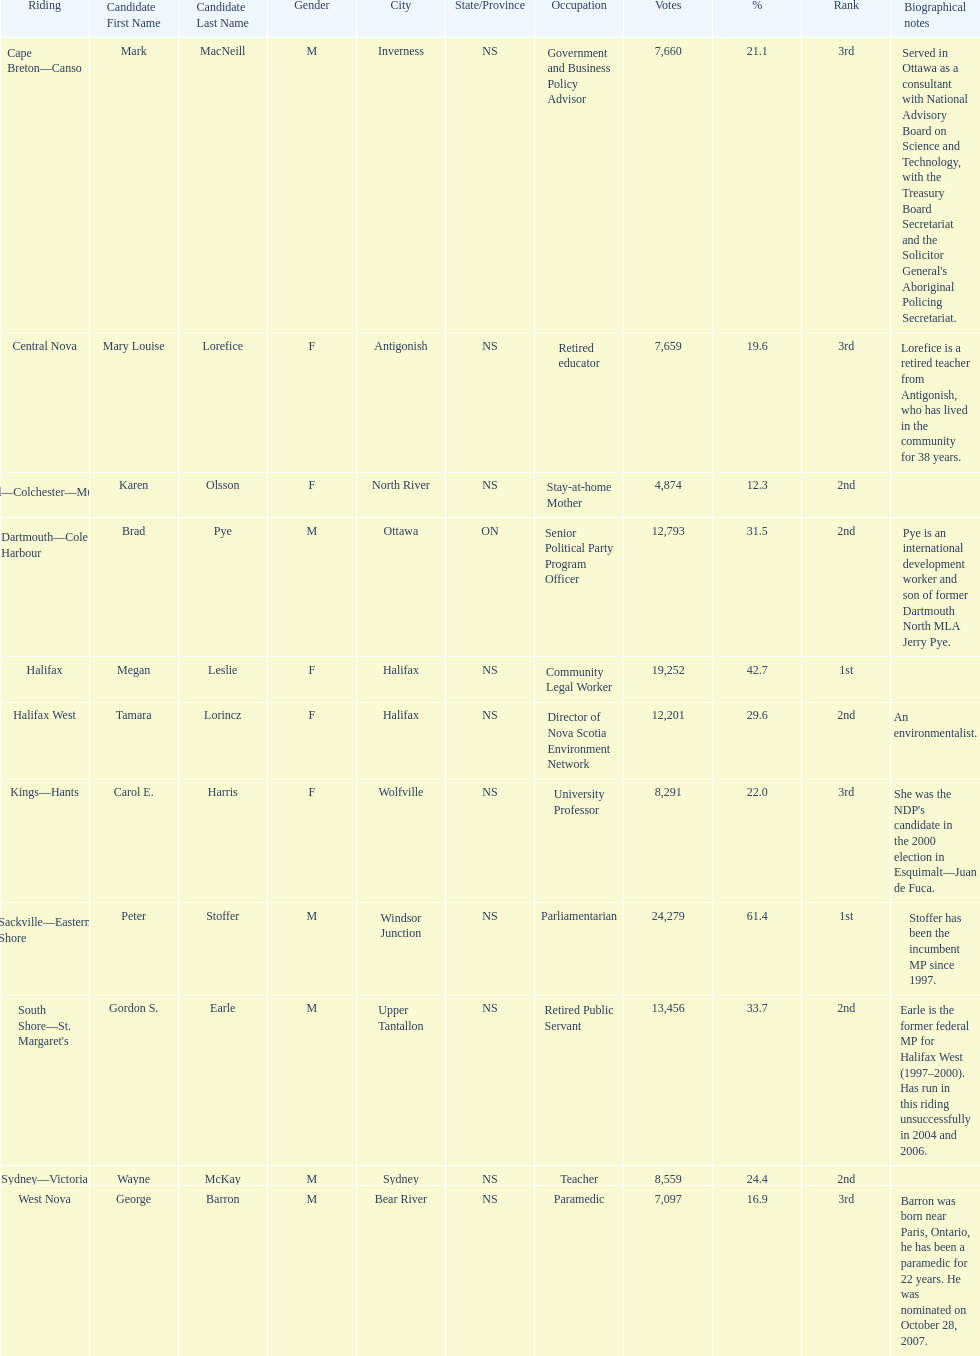How many candidates had more votes than tamara lorincz? 4. 